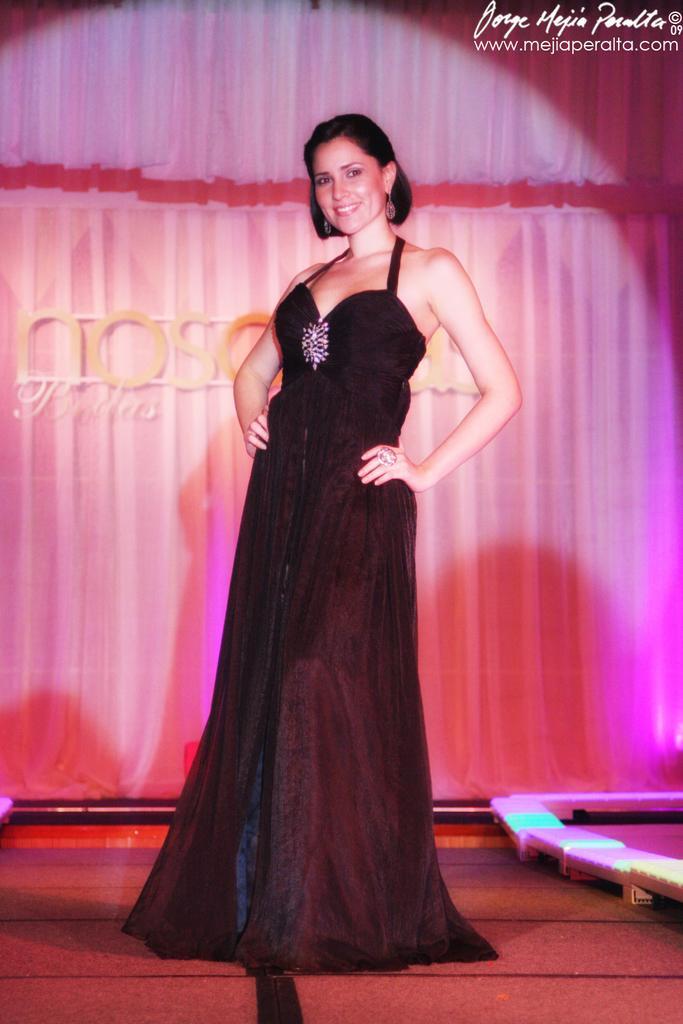Describe this image in one or two sentences. In this image in the center there is one woman who is standing and in the background there is wall and some curtains, at the bottom there is a floor. 